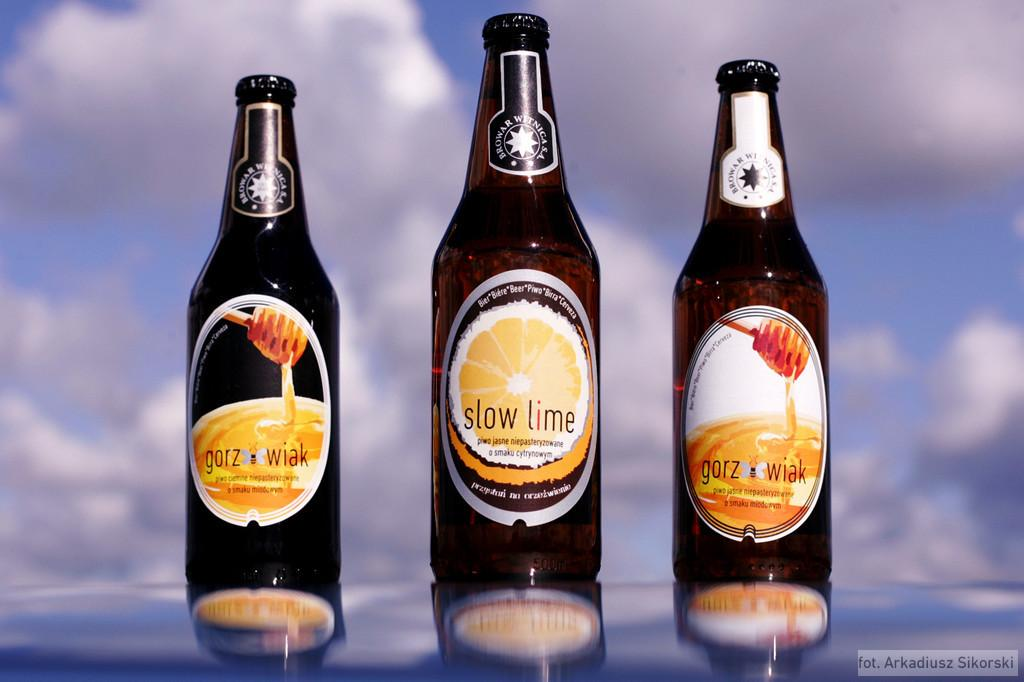<image>
Render a clear and concise summary of the photo. Slow lime beer bottle between two Gorz Wiak beer bottles. 